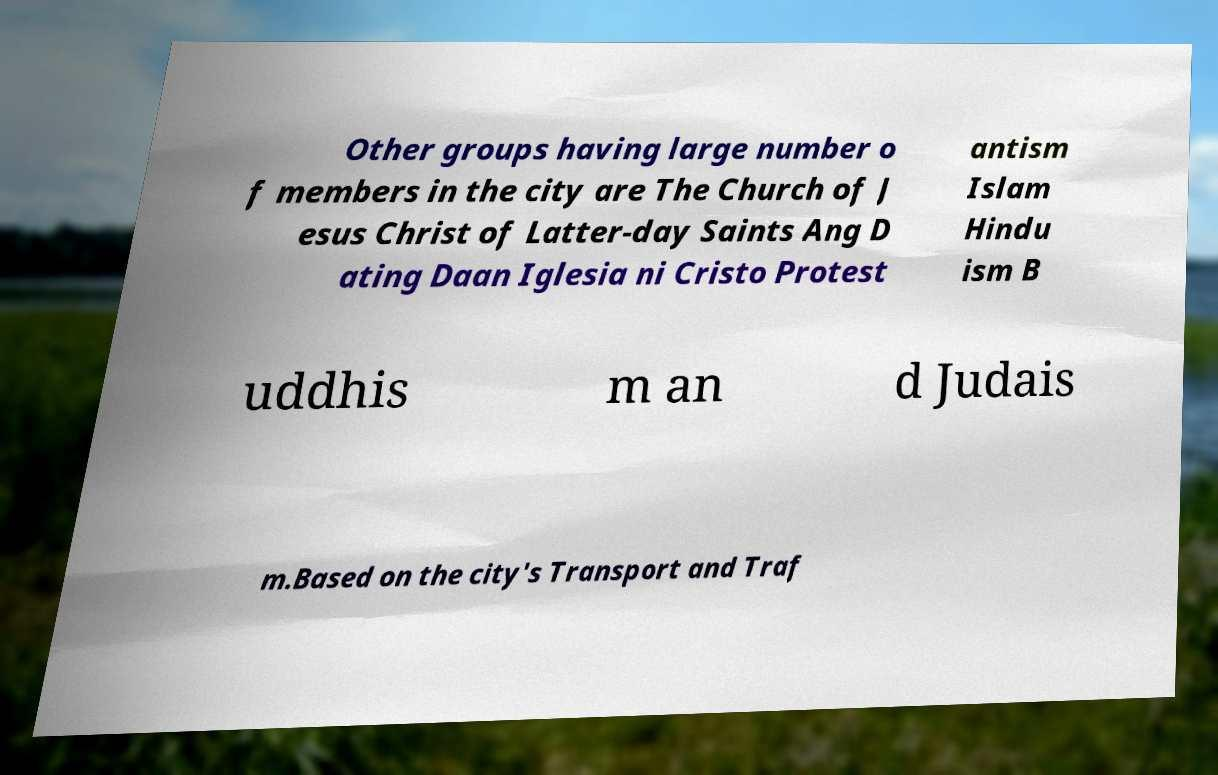I need the written content from this picture converted into text. Can you do that? Other groups having large number o f members in the city are The Church of J esus Christ of Latter-day Saints Ang D ating Daan Iglesia ni Cristo Protest antism Islam Hindu ism B uddhis m an d Judais m.Based on the city's Transport and Traf 